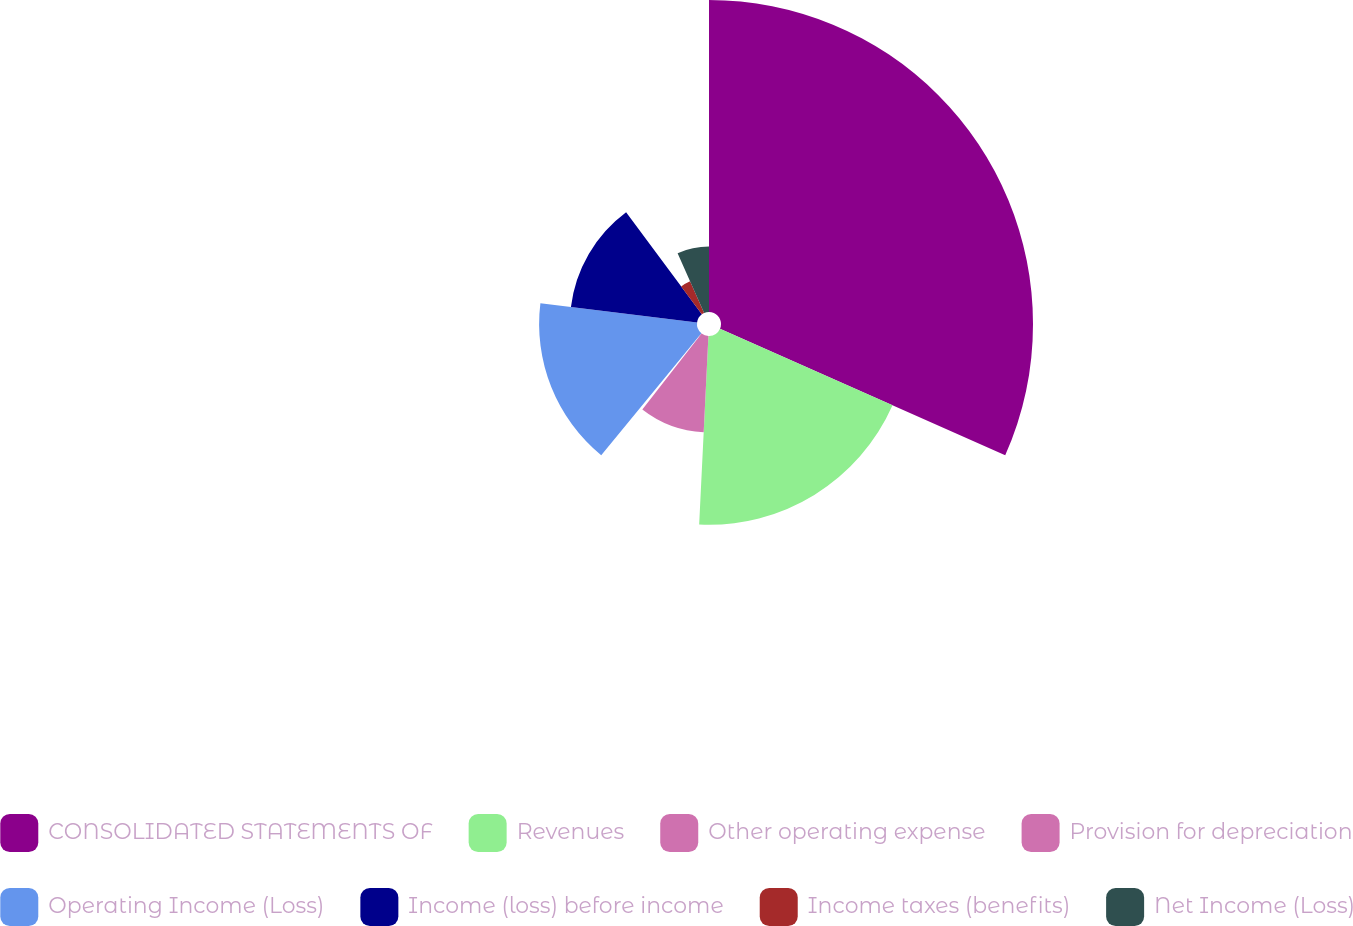<chart> <loc_0><loc_0><loc_500><loc_500><pie_chart><fcel>CONSOLIDATED STATEMENTS OF<fcel>Revenues<fcel>Other operating expense<fcel>Provision for depreciation<fcel>Operating Income (Loss)<fcel>Income (loss) before income<fcel>Income taxes (benefits)<fcel>Net Income (Loss)<nl><fcel>31.64%<fcel>19.14%<fcel>9.77%<fcel>0.39%<fcel>16.01%<fcel>12.89%<fcel>3.52%<fcel>6.64%<nl></chart> 